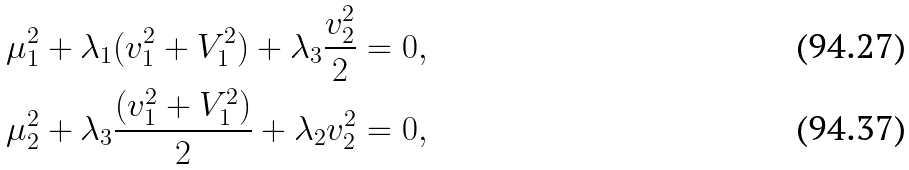Convert formula to latex. <formula><loc_0><loc_0><loc_500><loc_500>\mu _ { 1 } ^ { 2 } + \lambda _ { 1 } ( v _ { 1 } ^ { 2 } + V _ { 1 } ^ { 2 } ) + \lambda _ { 3 } \frac { v _ { 2 } ^ { 2 } } { 2 } & = 0 , \\ \mu _ { 2 } ^ { 2 } + \lambda _ { 3 } \frac { ( v _ { 1 } ^ { 2 } + V _ { 1 } ^ { 2 } ) } { 2 } + \lambda _ { 2 } v _ { 2 } ^ { 2 } & = 0 ,</formula> 